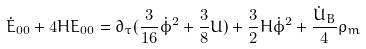Convert formula to latex. <formula><loc_0><loc_0><loc_500><loc_500>\dot { E } _ { 0 0 } + 4 H E _ { 0 0 } = \partial _ { \tau } ( \frac { 3 } { 1 6 } \dot { \phi } ^ { 2 } + \frac { 3 } { 8 } U ) + \frac { 3 } { 2 } H \dot { \phi } ^ { 2 } + \frac { \dot { U } _ { B } } { 4 } \rho _ { m }</formula> 